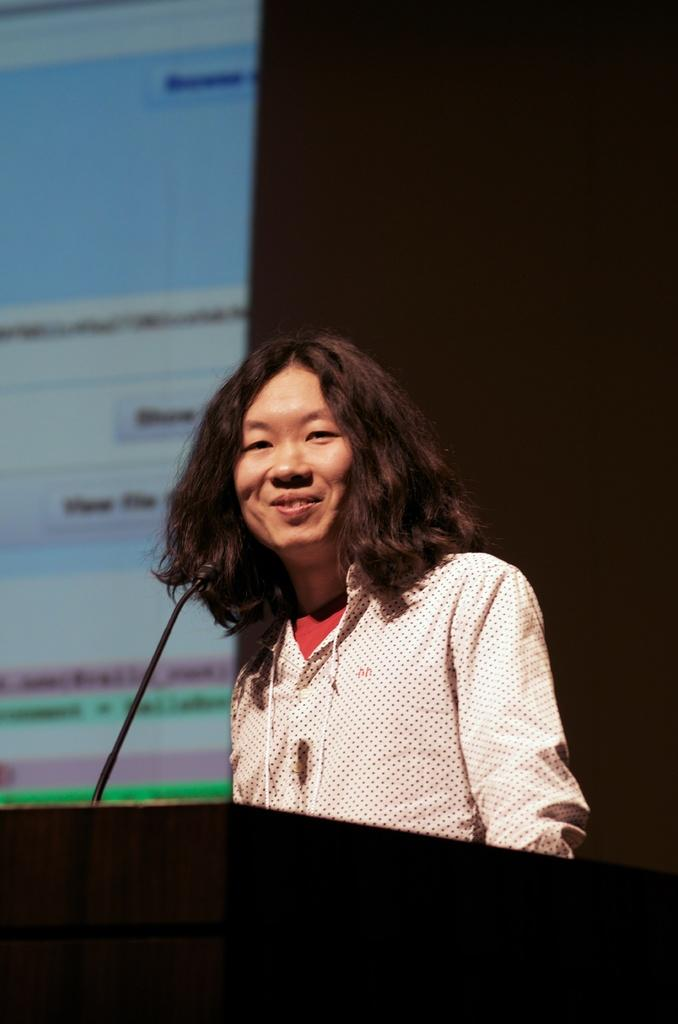Who is the main subject in the image? There is a woman in the image. What is the woman doing in the image? The woman is talking in front of a microphone. What else can be seen in the image besides the woman? There is a projected screen visible in the image. How many cows are visible on the projected screen in the image? There are no cows visible on the projected screen in the image. What type of toy is being used by the woman while talking in front of the microphone? There is no toy present in the image; the woman is simply talking in front of a microphone. 